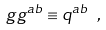<formula> <loc_0><loc_0><loc_500><loc_500>g g ^ { a b } \equiv q ^ { a b } \ ,</formula> 